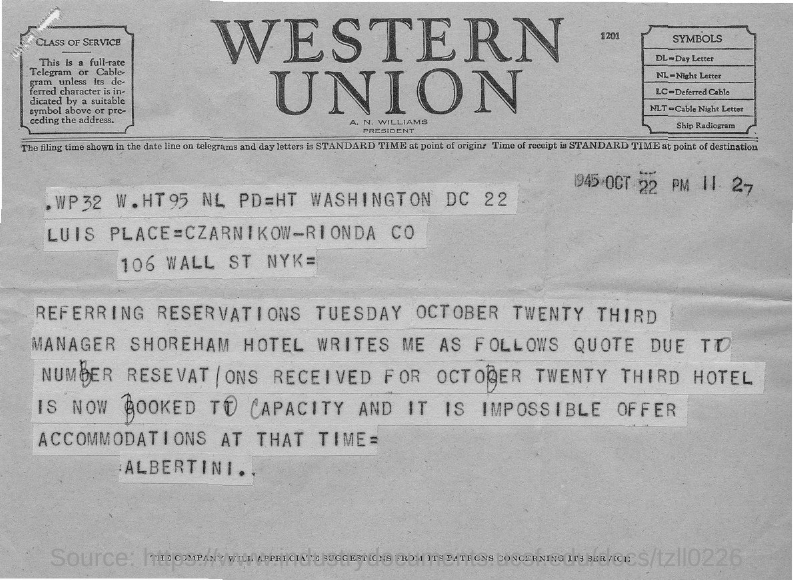Point out several critical features in this image. What does LC stand for in this document? Deferred Cable..." is a question asking for the meaning of a specific abbreviation in a document. What does DL stand for in this document? I believe it refers to a day letter. The president of Western Union is Norman Williams. The document is dated 1945 October 22. 